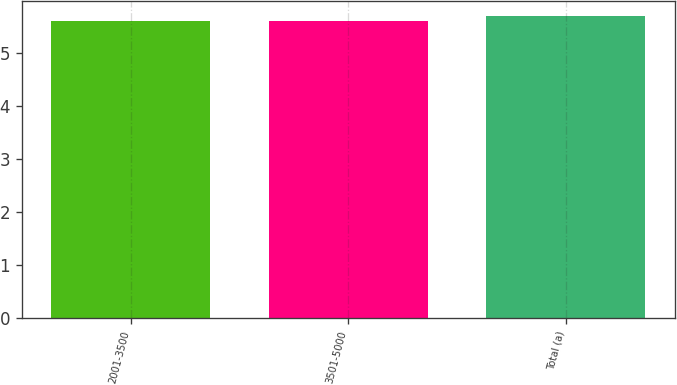Convert chart to OTSL. <chart><loc_0><loc_0><loc_500><loc_500><bar_chart><fcel>2001-3500<fcel>3501-5000<fcel>Total (a)<nl><fcel>5.6<fcel>5.61<fcel>5.7<nl></chart> 